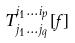Convert formula to latex. <formula><loc_0><loc_0><loc_500><loc_500>T _ { j _ { 1 } \dots j _ { q } } ^ { i _ { 1 } \dots i _ { p } } [ f ]</formula> 